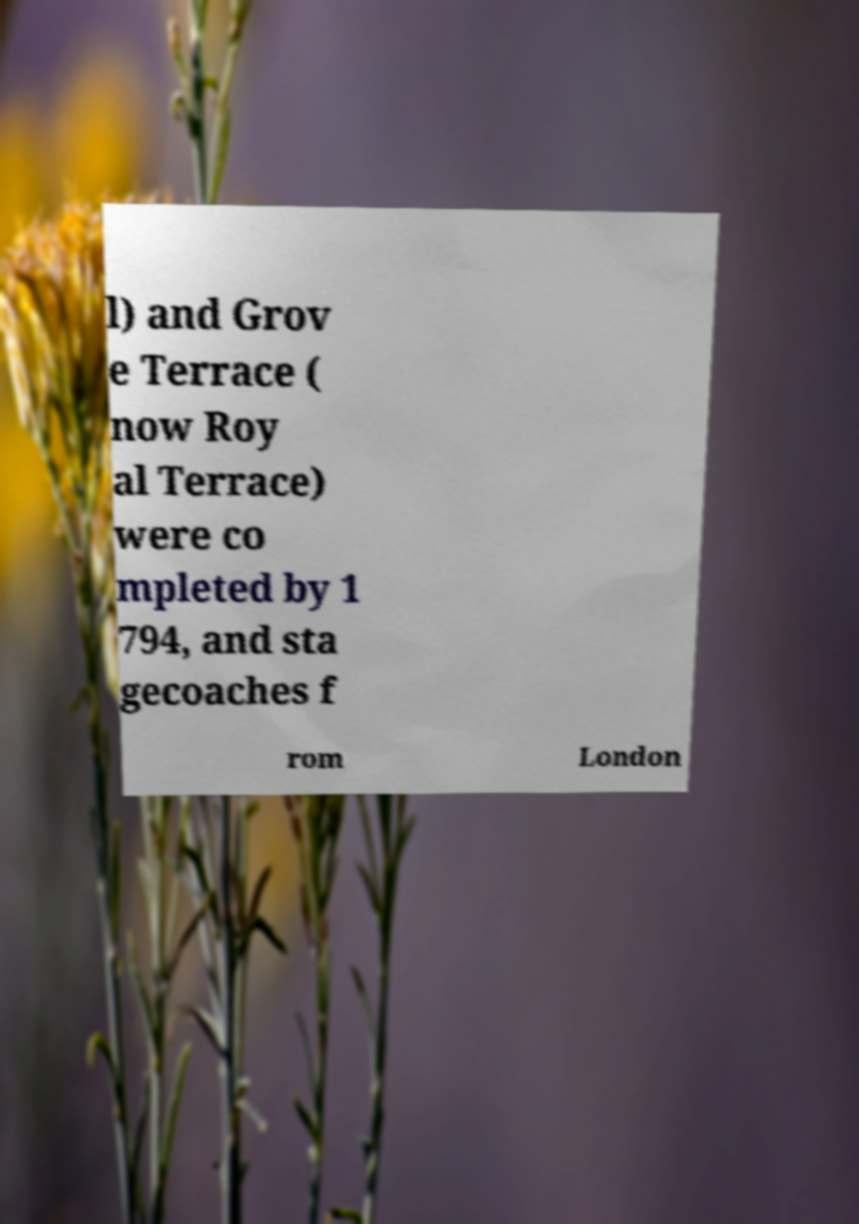Could you extract and type out the text from this image? l) and Grov e Terrace ( now Roy al Terrace) were co mpleted by 1 794, and sta gecoaches f rom London 